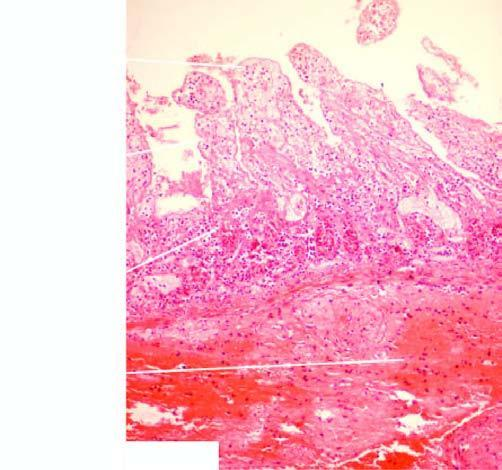does the mucosa in the infarcted area show coagulative necrosis and submucosal haemorrhages?
Answer the question using a single word or phrase. Yes 